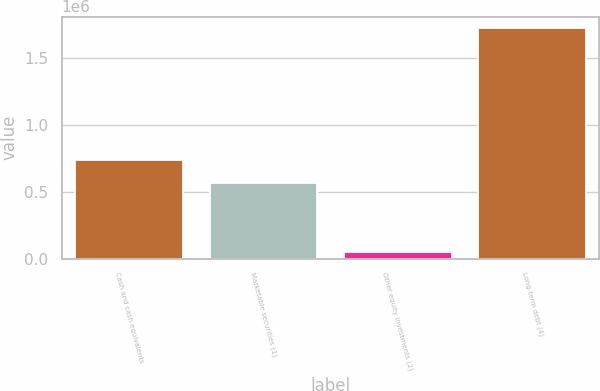Convert chart. <chart><loc_0><loc_0><loc_500><loc_500><bar_chart><fcel>Cash and cash equivalents<fcel>Marketable securities (1)<fcel>Other equity investments (2)<fcel>Long-term debt (4)<nl><fcel>738254<fcel>562715<fcel>46454<fcel>1.71911e+06<nl></chart> 